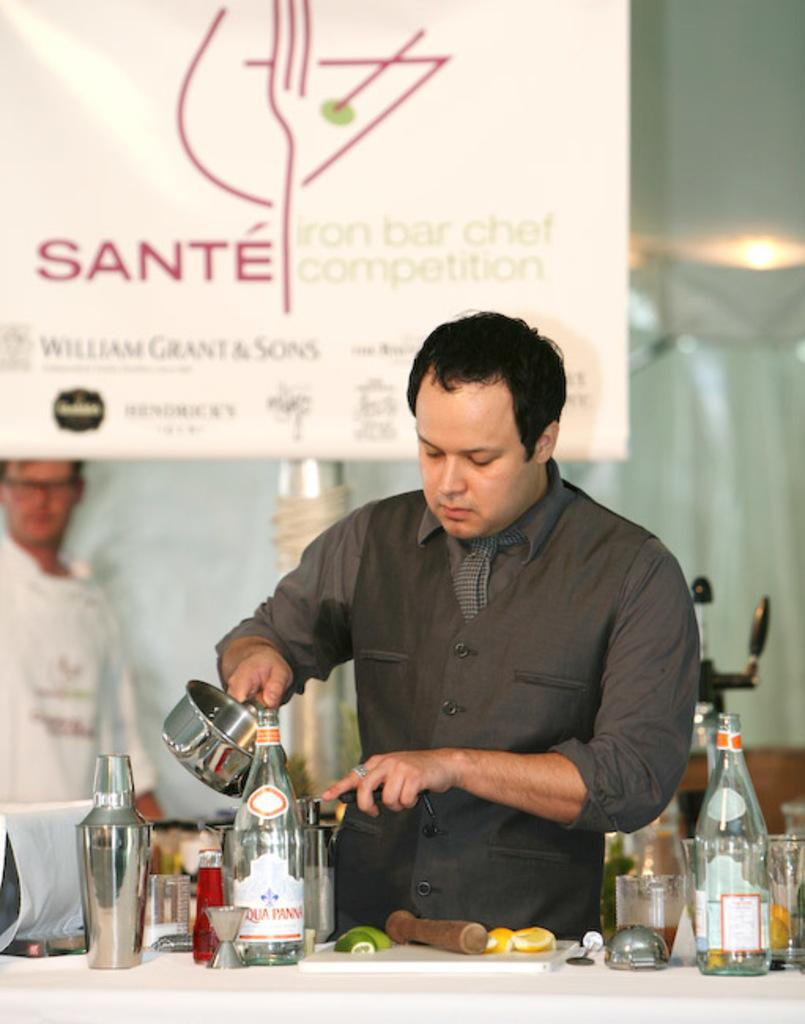<image>
Describe the image concisely. A man cooking in front of a Sante poster. 